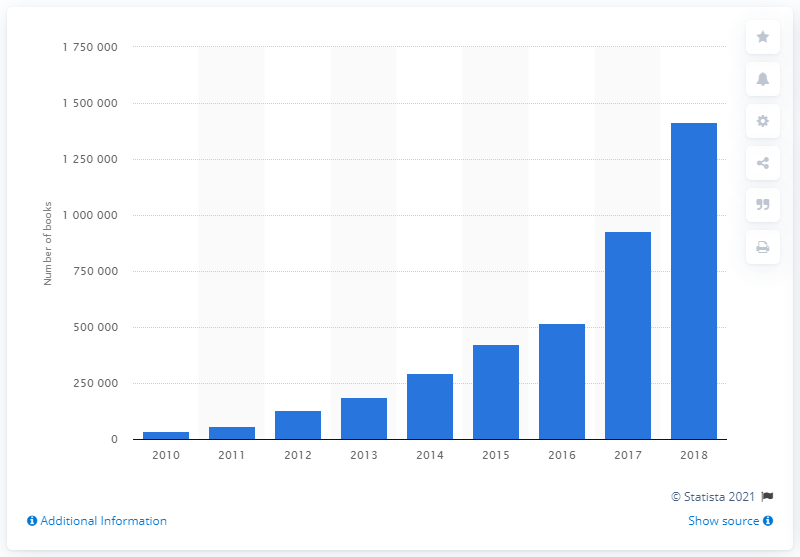Specify some key components in this picture. In 2017, CreateSpace published a total of 929,295 books. 